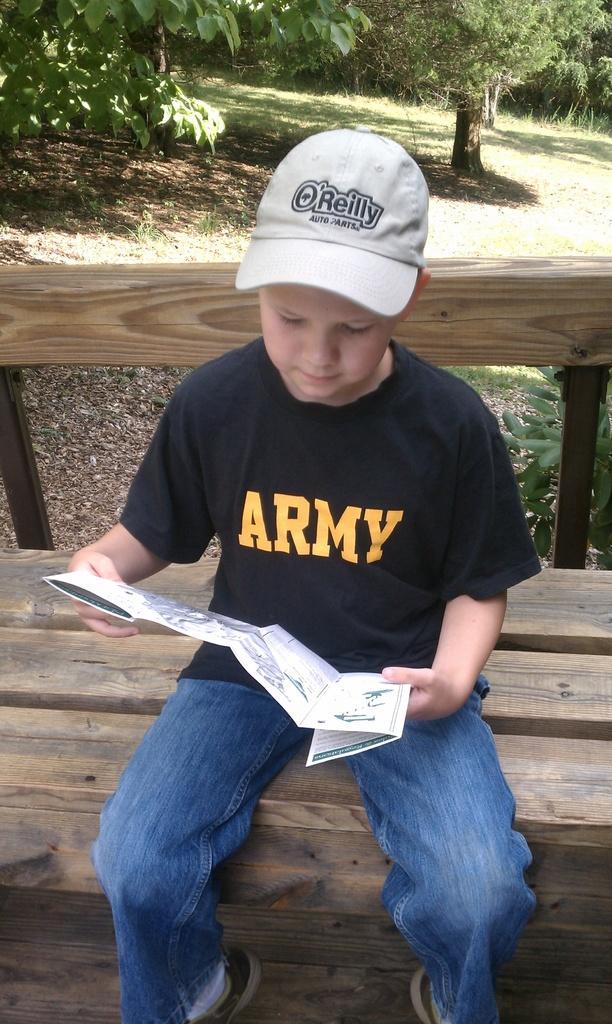Could you give a brief overview of what you see in this image? In this image there is a kid sitting on a bench is reading a pamphlet in his hand, behind the kid there are trees. 